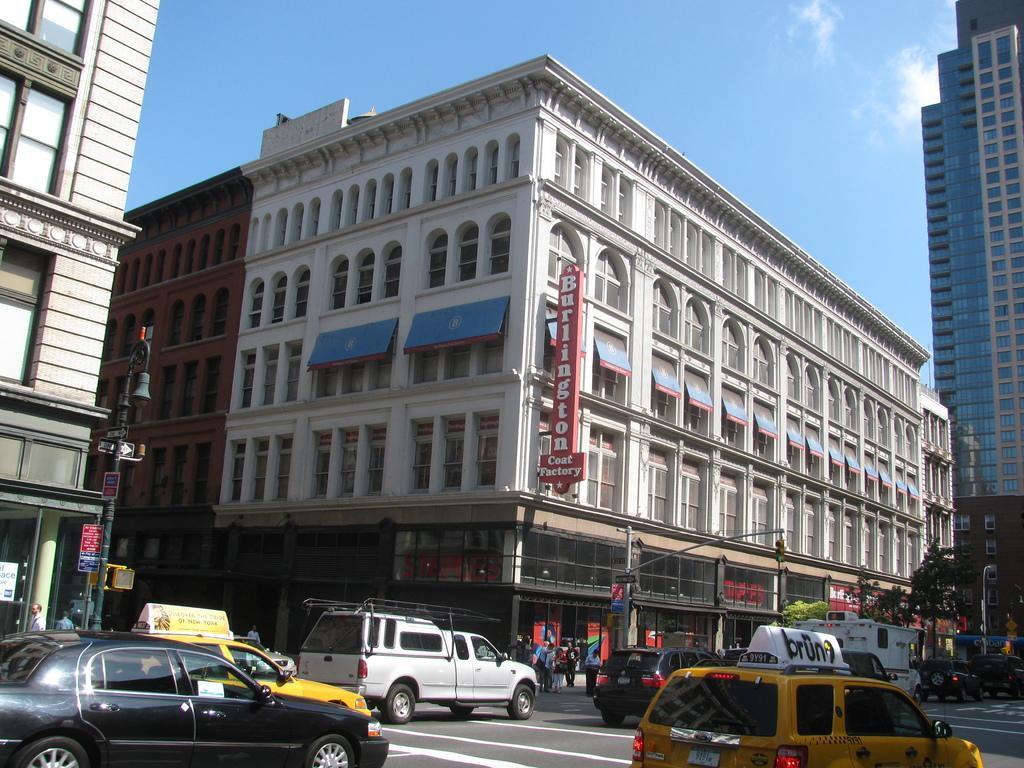<image>
Share a concise interpretation of the image provided. The front of Burlington Coat Factory with taxis on the street. 